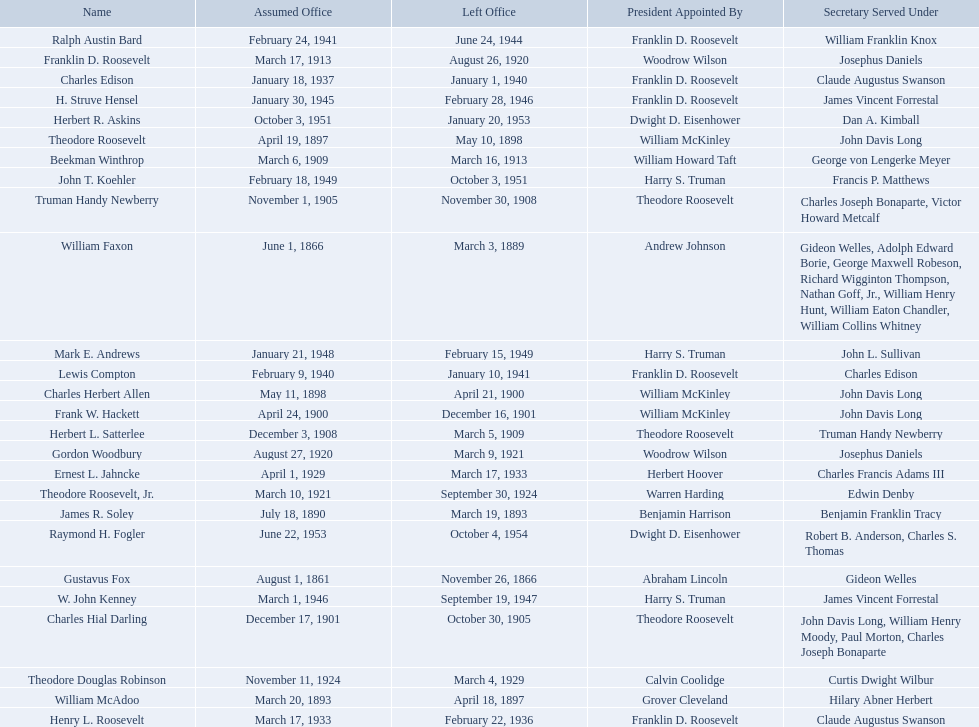Who were all the assistant secretary's of the navy? Gustavus Fox, William Faxon, James R. Soley, William McAdoo, Theodore Roosevelt, Charles Herbert Allen, Frank W. Hackett, Charles Hial Darling, Truman Handy Newberry, Herbert L. Satterlee, Beekman Winthrop, Franklin D. Roosevelt, Gordon Woodbury, Theodore Roosevelt, Jr., Theodore Douglas Robinson, Ernest L. Jahncke, Henry L. Roosevelt, Charles Edison, Lewis Compton, Ralph Austin Bard, H. Struve Hensel, W. John Kenney, Mark E. Andrews, John T. Koehler, Herbert R. Askins, Raymond H. Fogler. What are the various dates they left office in? November 26, 1866, March 3, 1889, March 19, 1893, April 18, 1897, May 10, 1898, April 21, 1900, December 16, 1901, October 30, 1905, November 30, 1908, March 5, 1909, March 16, 1913, August 26, 1920, March 9, 1921, September 30, 1924, March 4, 1929, March 17, 1933, February 22, 1936, January 1, 1940, January 10, 1941, June 24, 1944, February 28, 1946, September 19, 1947, February 15, 1949, October 3, 1951, January 20, 1953, October 4, 1954. Of these dates, which was the date raymond h. fogler left office in? October 4, 1954. What are all the names? Gustavus Fox, William Faxon, James R. Soley, William McAdoo, Theodore Roosevelt, Charles Herbert Allen, Frank W. Hackett, Charles Hial Darling, Truman Handy Newberry, Herbert L. Satterlee, Beekman Winthrop, Franklin D. Roosevelt, Gordon Woodbury, Theodore Roosevelt, Jr., Theodore Douglas Robinson, Ernest L. Jahncke, Henry L. Roosevelt, Charles Edison, Lewis Compton, Ralph Austin Bard, H. Struve Hensel, W. John Kenney, Mark E. Andrews, John T. Koehler, Herbert R. Askins, Raymond H. Fogler. Can you parse all the data within this table? {'header': ['Name', 'Assumed Office', 'Left Office', 'President Appointed By', 'Secretary Served Under'], 'rows': [['Ralph Austin Bard', 'February 24, 1941', 'June 24, 1944', 'Franklin D. Roosevelt', 'William Franklin Knox'], ['Franklin D. Roosevelt', 'March 17, 1913', 'August 26, 1920', 'Woodrow Wilson', 'Josephus Daniels'], ['Charles Edison', 'January 18, 1937', 'January 1, 1940', 'Franklin D. Roosevelt', 'Claude Augustus Swanson'], ['H. Struve Hensel', 'January 30, 1945', 'February 28, 1946', 'Franklin D. Roosevelt', 'James Vincent Forrestal'], ['Herbert R. Askins', 'October 3, 1951', 'January 20, 1953', 'Dwight D. Eisenhower', 'Dan A. Kimball'], ['Theodore Roosevelt', 'April 19, 1897', 'May 10, 1898', 'William McKinley', 'John Davis Long'], ['Beekman Winthrop', 'March 6, 1909', 'March 16, 1913', 'William Howard Taft', 'George von Lengerke Meyer'], ['John T. Koehler', 'February 18, 1949', 'October 3, 1951', 'Harry S. Truman', 'Francis P. Matthews'], ['Truman Handy Newberry', 'November 1, 1905', 'November 30, 1908', 'Theodore Roosevelt', 'Charles Joseph Bonaparte, Victor Howard Metcalf'], ['William Faxon', 'June 1, 1866', 'March 3, 1889', 'Andrew Johnson', 'Gideon Welles, Adolph Edward Borie, George Maxwell Robeson, Richard Wigginton Thompson, Nathan Goff, Jr., William Henry Hunt, William Eaton Chandler, William Collins Whitney'], ['Mark E. Andrews', 'January 21, 1948', 'February 15, 1949', 'Harry S. Truman', 'John L. Sullivan'], ['Lewis Compton', 'February 9, 1940', 'January 10, 1941', 'Franklin D. Roosevelt', 'Charles Edison'], ['Charles Herbert Allen', 'May 11, 1898', 'April 21, 1900', 'William McKinley', 'John Davis Long'], ['Frank W. Hackett', 'April 24, 1900', 'December 16, 1901', 'William McKinley', 'John Davis Long'], ['Herbert L. Satterlee', 'December 3, 1908', 'March 5, 1909', 'Theodore Roosevelt', 'Truman Handy Newberry'], ['Gordon Woodbury', 'August 27, 1920', 'March 9, 1921', 'Woodrow Wilson', 'Josephus Daniels'], ['Ernest L. Jahncke', 'April 1, 1929', 'March 17, 1933', 'Herbert Hoover', 'Charles Francis Adams III'], ['Theodore Roosevelt, Jr.', 'March 10, 1921', 'September 30, 1924', 'Warren Harding', 'Edwin Denby'], ['James R. Soley', 'July 18, 1890', 'March 19, 1893', 'Benjamin Harrison', 'Benjamin Franklin Tracy'], ['Raymond H. Fogler', 'June 22, 1953', 'October 4, 1954', 'Dwight D. Eisenhower', 'Robert B. Anderson, Charles S. Thomas'], ['Gustavus Fox', 'August 1, 1861', 'November 26, 1866', 'Abraham Lincoln', 'Gideon Welles'], ['W. John Kenney', 'March 1, 1946', 'September 19, 1947', 'Harry S. Truman', 'James Vincent Forrestal'], ['Charles Hial Darling', 'December 17, 1901', 'October 30, 1905', 'Theodore Roosevelt', 'John Davis Long, William Henry Moody, Paul Morton, Charles Joseph Bonaparte'], ['Theodore Douglas Robinson', 'November 11, 1924', 'March 4, 1929', 'Calvin Coolidge', 'Curtis Dwight Wilbur'], ['William McAdoo', 'March 20, 1893', 'April 18, 1897', 'Grover Cleveland', 'Hilary Abner Herbert'], ['Henry L. Roosevelt', 'March 17, 1933', 'February 22, 1936', 'Franklin D. Roosevelt', 'Claude Augustus Swanson']]} When did they leave office? November 26, 1866, March 3, 1889, March 19, 1893, April 18, 1897, May 10, 1898, April 21, 1900, December 16, 1901, October 30, 1905, November 30, 1908, March 5, 1909, March 16, 1913, August 26, 1920, March 9, 1921, September 30, 1924, March 4, 1929, March 17, 1933, February 22, 1936, January 1, 1940, January 10, 1941, June 24, 1944, February 28, 1946, September 19, 1947, February 15, 1949, October 3, 1951, January 20, 1953, October 4, 1954. And when did raymond h. fogler leave? October 4, 1954. 